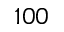Convert formula to latex. <formula><loc_0><loc_0><loc_500><loc_500>1 0 0</formula> 